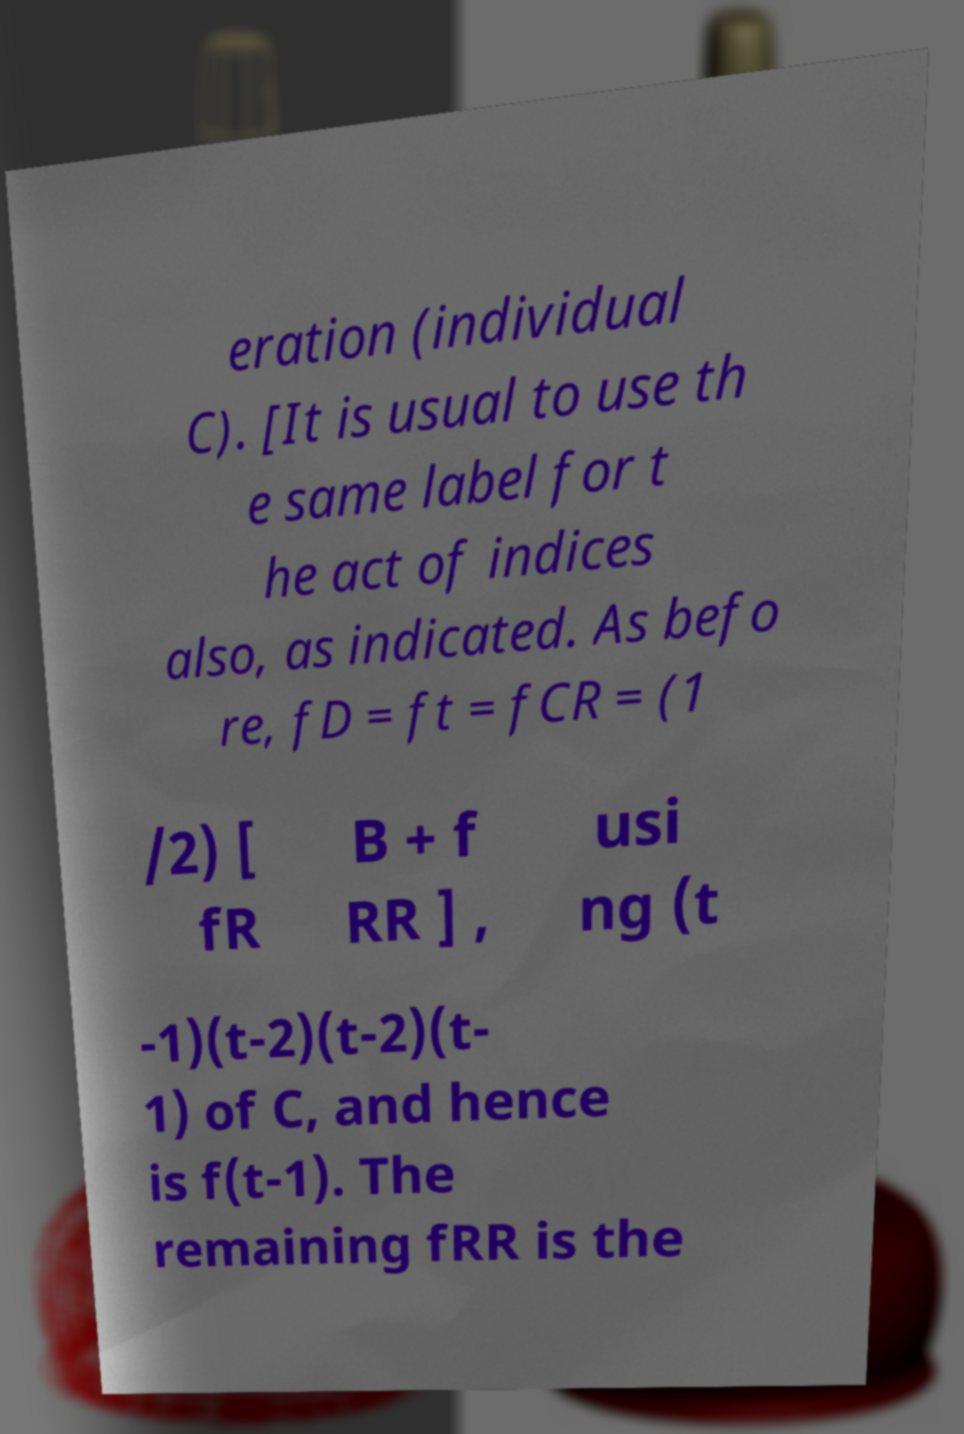What messages or text are displayed in this image? I need them in a readable, typed format. eration (individual C). [It is usual to use th e same label for t he act of indices also, as indicated. As befo re, fD = ft = fCR = (1 /2) [ fR B + f RR ] , usi ng (t -1)(t-2)(t-2)(t- 1) of C, and hence is f(t-1). The remaining fRR is the 